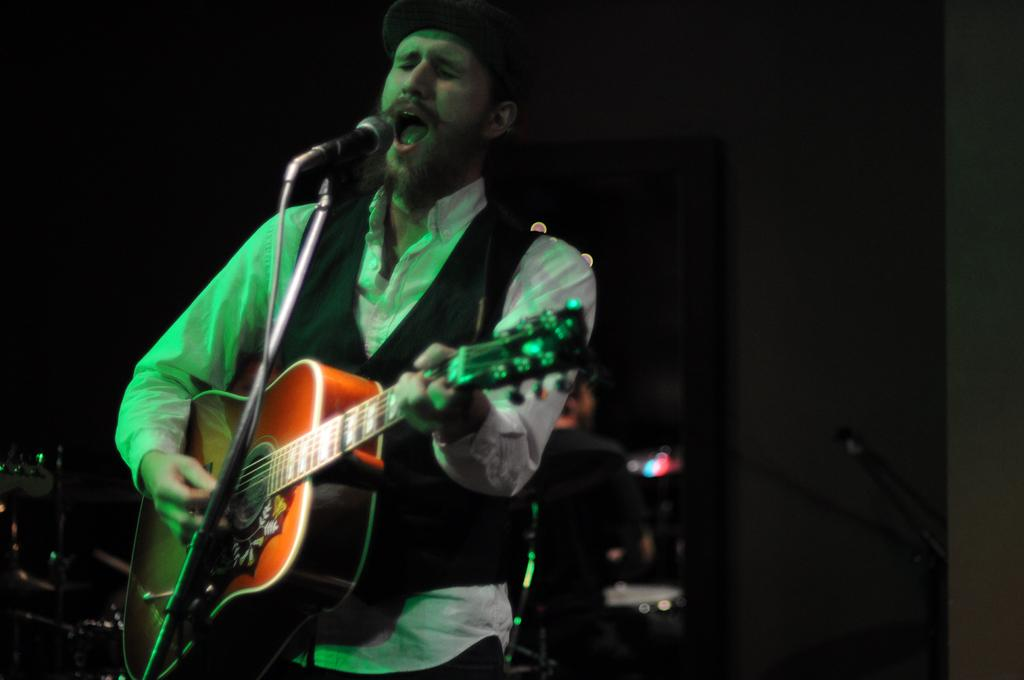What is the man in the image doing? The man is singing in the image. What is the man holding while singing? The man is holding a microphone. What musical instrument is the man playing? The man is playing a guitar. What type of fang can be seen in the man's mouth while he is singing? There is no fang visible in the man's mouth in the image. Who is the man's friend in the image? The provided facts do not mention any friends or other people in the image. 